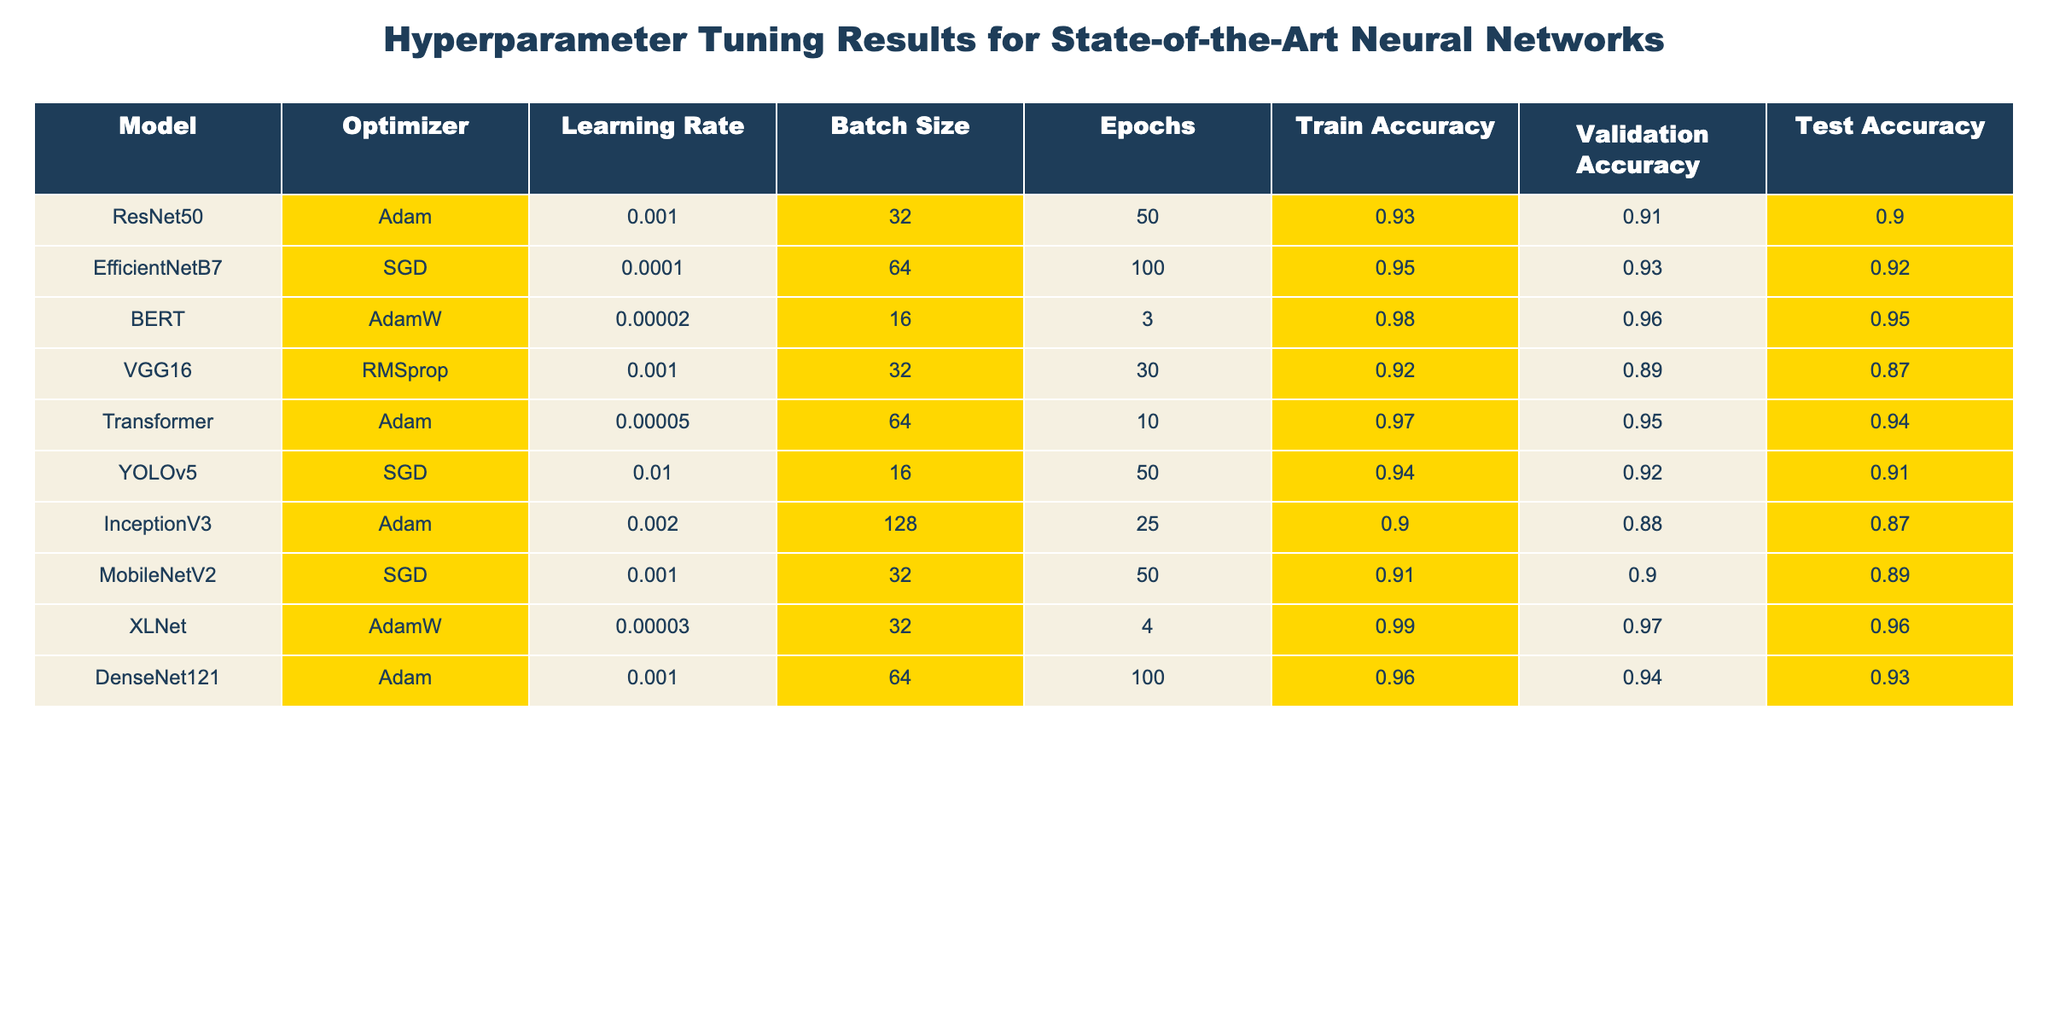What is the test accuracy of the BERT model? The test accuracy of the BERT model is listed in the table under the "Test Accuracy" column for the row corresponding to BERT. The value is 0.95.
Answer: 0.95 Which optimizer is used for DenseNet121? The optimizer used for DenseNet121 can be found in the "Optimizer" column for the row corresponding to DenseNet121. It shows Adam.
Answer: Adam What is the average training accuracy across all models? To find the average training accuracy, we sum the training accuracies of all models: (0.93 + 0.95 + 0.98 + 0.92 + 0.97 + 0.94 + 0.90 + 0.91 + 0.99 + 0.96) = 9.15. We then divide by the number of models, which is 10 (9.15/10 = 0.915).
Answer: 0.915 Is the validation accuracy of EfficientNetB7 higher than that of VGG16? The validation accuracy for EfficientNetB7 is 0.93, and for VGG16 it is 0.89. Comparing the two values shows that 0.93 is greater than 0.89, confirming that EfficientNetB7 has a higher validation accuracy.
Answer: Yes Which model has the highest training accuracy and what is its value? By examining the "Train Accuracy" column, we notice that XLNet has the highest training accuracy at 0.99 when compared to the other models listed.
Answer: XLNet, 0.99 What is the difference in test accuracy between YOLOv5 and InceptionV3? The test accuracy for YOLOv5 is 0.91 and for InceptionV3 it is 0.87. To find the difference, we subtract InceptionV3’s accuracy from YOLOv5’s: 0.91 - 0.87 = 0.04.
Answer: 0.04 Does the batch size have any impact on the validation accuracy of models using Adam optimizer? Analyzing the table, we find that ResNet50 (batch size 32, validation accuracy 0.91) and DenseNet121 (batch size 64, validation accuracy 0.94) both use the Adam optimizer. The validation accuracy is higher for DenseNet121, indicating that a larger batch size might relate to better validation accuracy in this case.
Answer: Yes What is the highest learning rate among the models listed? To find the highest learning rate, we review the "Learning Rate" column. The highest learning rate value, clearly listed, is 0.01 for YOLOv5.
Answer: 0.01 Which model has the lowest validation accuracy? The lowest validation accuracy can be determined by looking through the "Validation Accuracy" column for all models. The minimum value is 0.87, associated with the InceptionV3 model.
Answer: InceptionV3, 0.87 